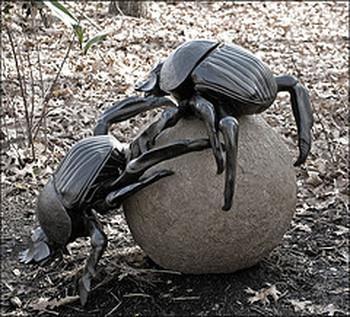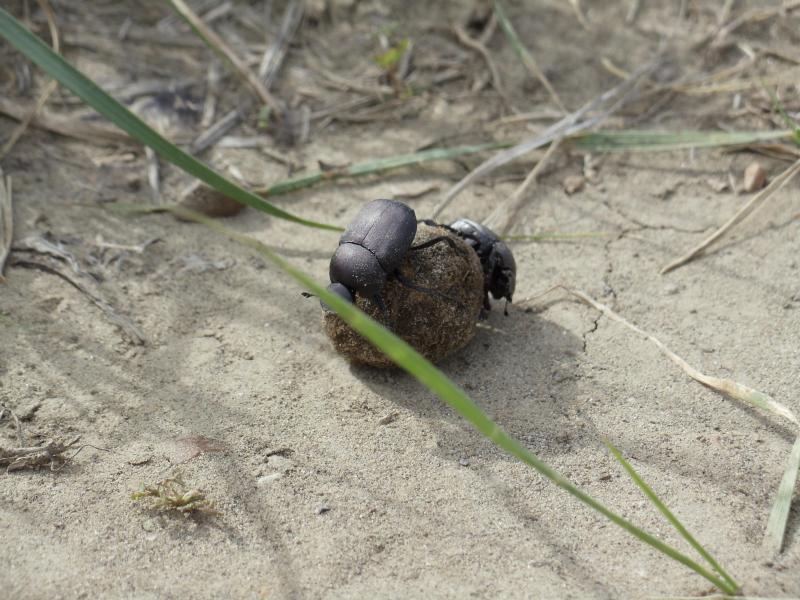The first image is the image on the left, the second image is the image on the right. Assess this claim about the two images: "One image contains a black beetle but no brown ball, and the other contains one brown ball and at least one beetle.". Correct or not? Answer yes or no. No. The first image is the image on the left, the second image is the image on the right. Analyze the images presented: Is the assertion "There are at most three beetles." valid? Answer yes or no. No. 